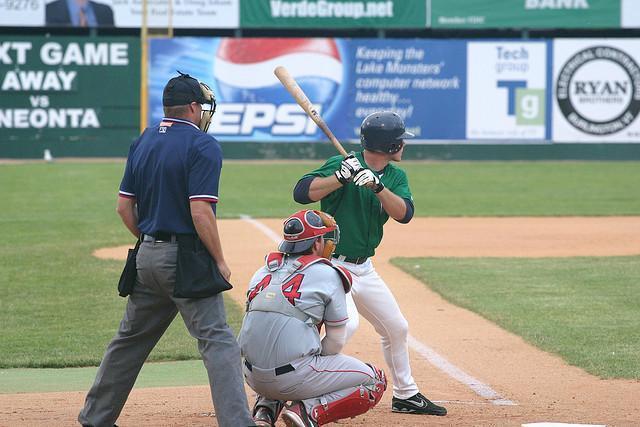How many people are in the picture?
Give a very brief answer. 3. 